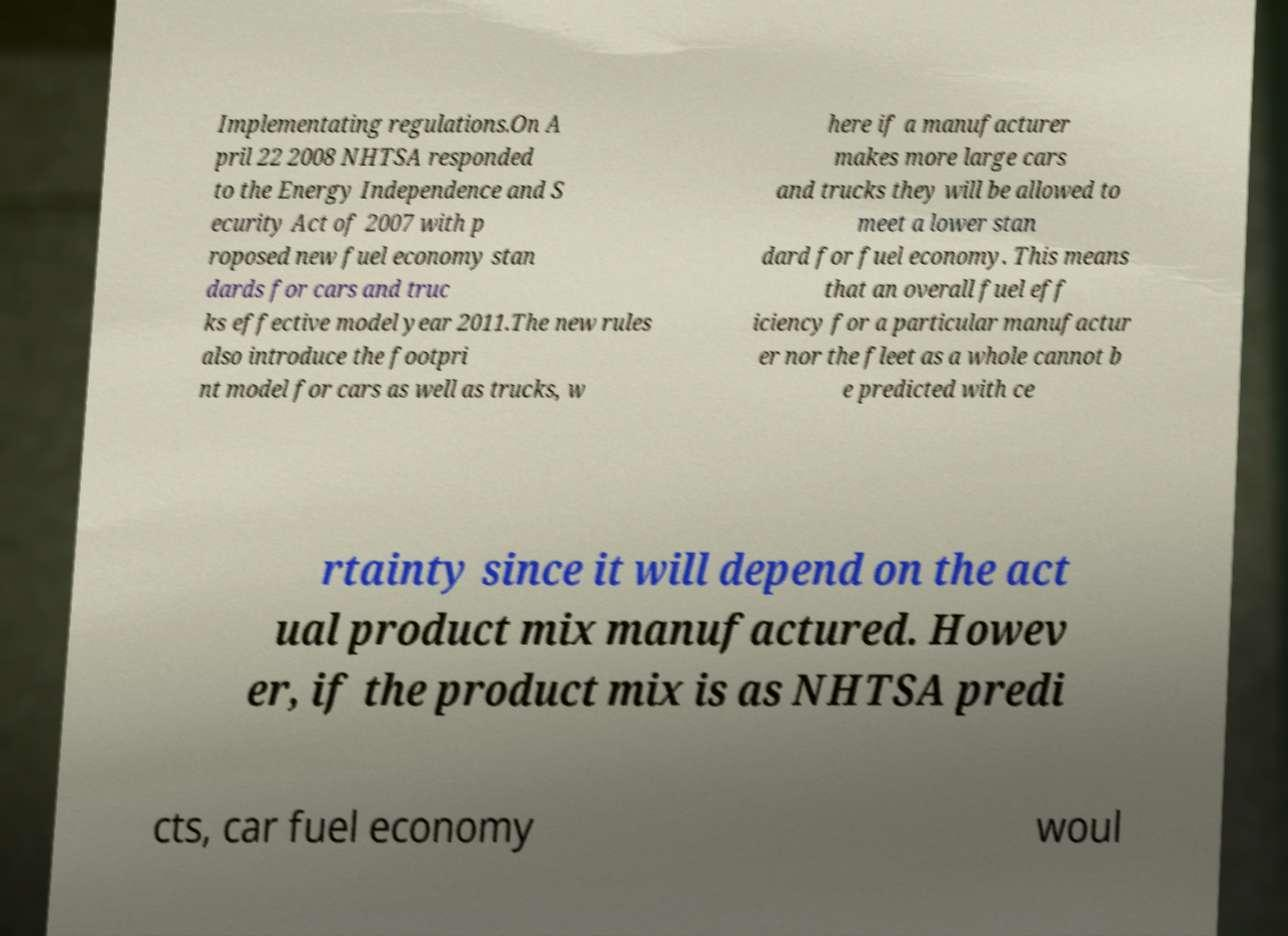Please identify and transcribe the text found in this image. Implementating regulations.On A pril 22 2008 NHTSA responded to the Energy Independence and S ecurity Act of 2007 with p roposed new fuel economy stan dards for cars and truc ks effective model year 2011.The new rules also introduce the footpri nt model for cars as well as trucks, w here if a manufacturer makes more large cars and trucks they will be allowed to meet a lower stan dard for fuel economy. This means that an overall fuel eff iciency for a particular manufactur er nor the fleet as a whole cannot b e predicted with ce rtainty since it will depend on the act ual product mix manufactured. Howev er, if the product mix is as NHTSA predi cts, car fuel economy woul 